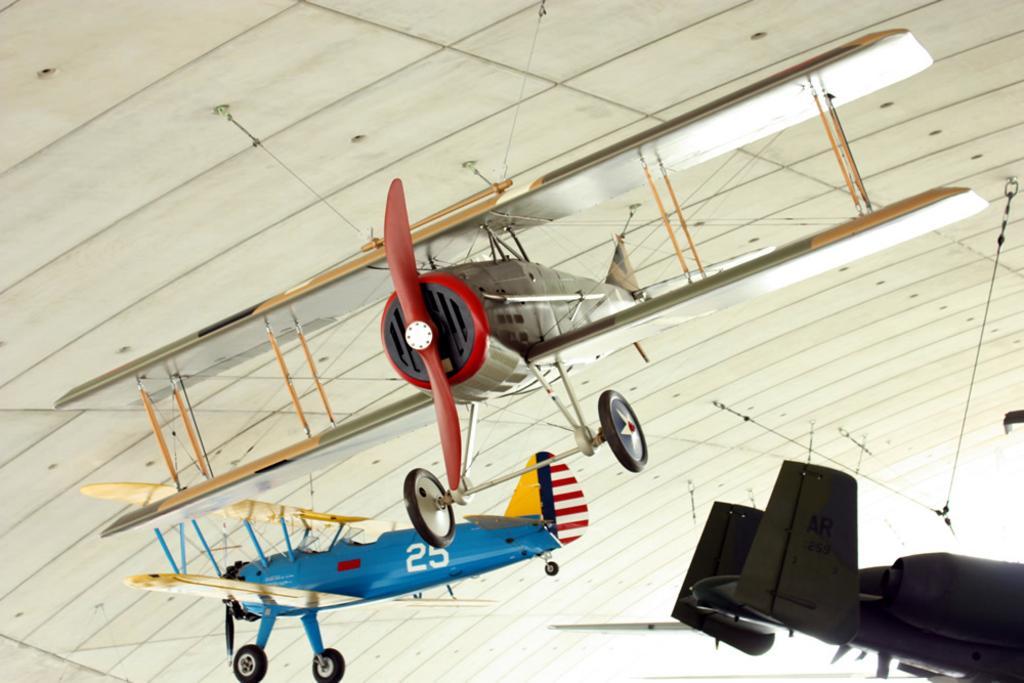Can you describe this image briefly? This picture is clicked inside. In the center we can see the aircrafts of different colors are hanging on the roof. At the top we can see the roof. 